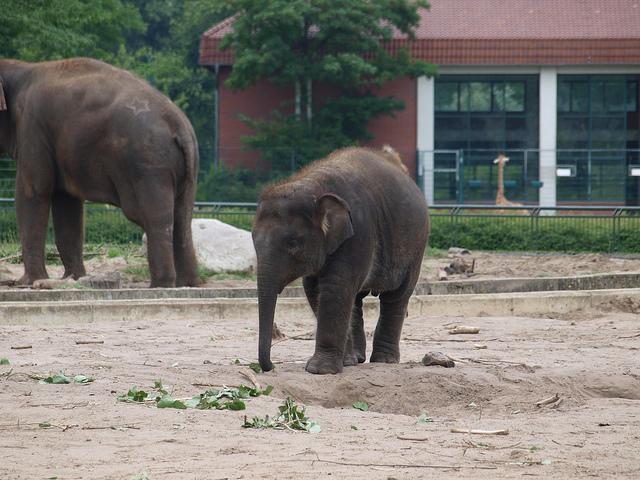How many different sizes of elephants are visible?
Give a very brief answer. 2. How many elephants can be seen?
Give a very brief answer. 2. 